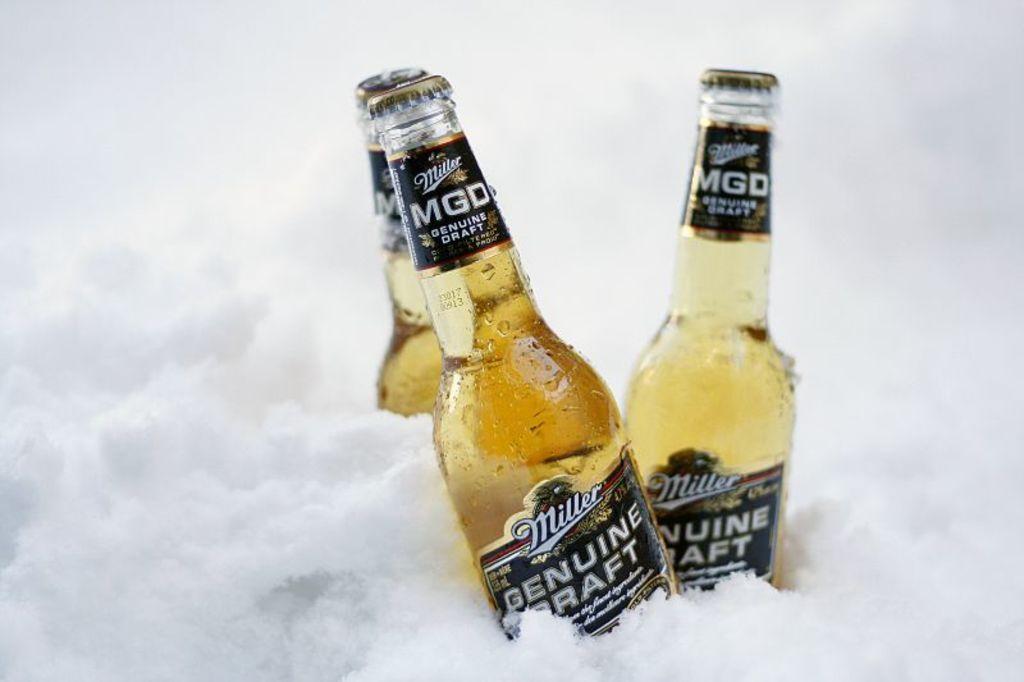Is this miller?
Offer a very short reply. Yes. What type of miller beer is this?
Make the answer very short. Genuine draft. 